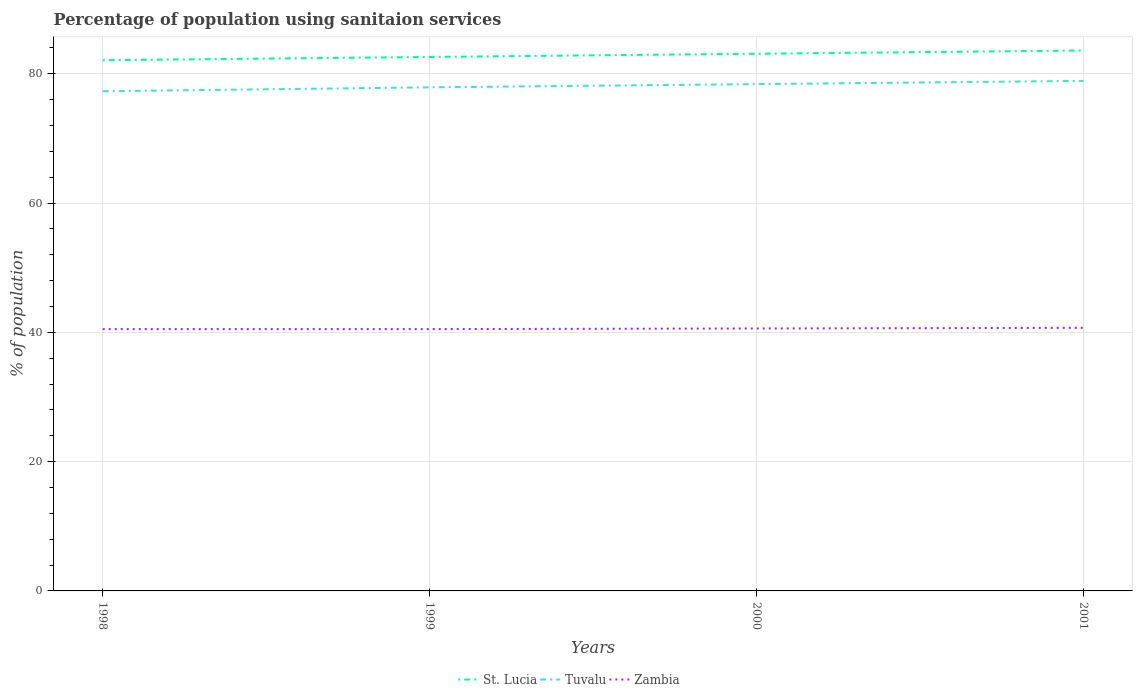How many different coloured lines are there?
Offer a very short reply. 3. Does the line corresponding to St. Lucia intersect with the line corresponding to Tuvalu?
Offer a very short reply. No. Is the number of lines equal to the number of legend labels?
Your answer should be very brief. Yes. Across all years, what is the maximum percentage of population using sanitaion services in Zambia?
Keep it short and to the point. 40.5. What is the total percentage of population using sanitaion services in Tuvalu in the graph?
Offer a very short reply. -1.6. What is the difference between the highest and the second highest percentage of population using sanitaion services in Tuvalu?
Make the answer very short. 1.6. What is the difference between the highest and the lowest percentage of population using sanitaion services in Tuvalu?
Keep it short and to the point. 2. Is the percentage of population using sanitaion services in St. Lucia strictly greater than the percentage of population using sanitaion services in Tuvalu over the years?
Provide a succinct answer. No. How many lines are there?
Offer a very short reply. 3. What is the difference between two consecutive major ticks on the Y-axis?
Your answer should be compact. 20. Does the graph contain any zero values?
Give a very brief answer. No. Where does the legend appear in the graph?
Give a very brief answer. Bottom center. How many legend labels are there?
Offer a terse response. 3. How are the legend labels stacked?
Offer a very short reply. Horizontal. What is the title of the graph?
Offer a terse response. Percentage of population using sanitaion services. Does "Bhutan" appear as one of the legend labels in the graph?
Your answer should be very brief. No. What is the label or title of the Y-axis?
Offer a very short reply. % of population. What is the % of population in St. Lucia in 1998?
Give a very brief answer. 82.1. What is the % of population in Tuvalu in 1998?
Make the answer very short. 77.3. What is the % of population of Zambia in 1998?
Give a very brief answer. 40.5. What is the % of population of St. Lucia in 1999?
Give a very brief answer. 82.6. What is the % of population of Tuvalu in 1999?
Offer a terse response. 77.9. What is the % of population in Zambia in 1999?
Give a very brief answer. 40.5. What is the % of population of St. Lucia in 2000?
Offer a very short reply. 83.1. What is the % of population in Tuvalu in 2000?
Give a very brief answer. 78.4. What is the % of population of Zambia in 2000?
Your answer should be very brief. 40.6. What is the % of population in St. Lucia in 2001?
Your response must be concise. 83.6. What is the % of population in Tuvalu in 2001?
Offer a very short reply. 78.9. What is the % of population of Zambia in 2001?
Offer a terse response. 40.7. Across all years, what is the maximum % of population in St. Lucia?
Make the answer very short. 83.6. Across all years, what is the maximum % of population in Tuvalu?
Ensure brevity in your answer.  78.9. Across all years, what is the maximum % of population in Zambia?
Offer a very short reply. 40.7. Across all years, what is the minimum % of population in St. Lucia?
Make the answer very short. 82.1. Across all years, what is the minimum % of population of Tuvalu?
Provide a short and direct response. 77.3. Across all years, what is the minimum % of population of Zambia?
Your response must be concise. 40.5. What is the total % of population of St. Lucia in the graph?
Offer a terse response. 331.4. What is the total % of population in Tuvalu in the graph?
Offer a terse response. 312.5. What is the total % of population in Zambia in the graph?
Offer a terse response. 162.3. What is the difference between the % of population in St. Lucia in 1998 and that in 1999?
Ensure brevity in your answer.  -0.5. What is the difference between the % of population in Tuvalu in 1998 and that in 1999?
Your response must be concise. -0.6. What is the difference between the % of population of Tuvalu in 1998 and that in 2000?
Offer a terse response. -1.1. What is the difference between the % of population of Zambia in 1998 and that in 2000?
Provide a short and direct response. -0.1. What is the difference between the % of population in St. Lucia in 1998 and that in 2001?
Provide a short and direct response. -1.5. What is the difference between the % of population in Tuvalu in 1998 and that in 2001?
Ensure brevity in your answer.  -1.6. What is the difference between the % of population of Zambia in 1998 and that in 2001?
Offer a terse response. -0.2. What is the difference between the % of population in Tuvalu in 1999 and that in 2000?
Give a very brief answer. -0.5. What is the difference between the % of population in Tuvalu in 1999 and that in 2001?
Offer a very short reply. -1. What is the difference between the % of population in Zambia in 1999 and that in 2001?
Provide a succinct answer. -0.2. What is the difference between the % of population of St. Lucia in 1998 and the % of population of Tuvalu in 1999?
Offer a terse response. 4.2. What is the difference between the % of population of St. Lucia in 1998 and the % of population of Zambia in 1999?
Give a very brief answer. 41.6. What is the difference between the % of population of Tuvalu in 1998 and the % of population of Zambia in 1999?
Your answer should be compact. 36.8. What is the difference between the % of population of St. Lucia in 1998 and the % of population of Zambia in 2000?
Offer a terse response. 41.5. What is the difference between the % of population of Tuvalu in 1998 and the % of population of Zambia in 2000?
Provide a succinct answer. 36.7. What is the difference between the % of population in St. Lucia in 1998 and the % of population in Tuvalu in 2001?
Ensure brevity in your answer.  3.2. What is the difference between the % of population in St. Lucia in 1998 and the % of population in Zambia in 2001?
Your answer should be very brief. 41.4. What is the difference between the % of population of Tuvalu in 1998 and the % of population of Zambia in 2001?
Make the answer very short. 36.6. What is the difference between the % of population in St. Lucia in 1999 and the % of population in Tuvalu in 2000?
Your answer should be very brief. 4.2. What is the difference between the % of population of Tuvalu in 1999 and the % of population of Zambia in 2000?
Ensure brevity in your answer.  37.3. What is the difference between the % of population of St. Lucia in 1999 and the % of population of Zambia in 2001?
Your answer should be very brief. 41.9. What is the difference between the % of population of Tuvalu in 1999 and the % of population of Zambia in 2001?
Your response must be concise. 37.2. What is the difference between the % of population in St. Lucia in 2000 and the % of population in Zambia in 2001?
Give a very brief answer. 42.4. What is the difference between the % of population in Tuvalu in 2000 and the % of population in Zambia in 2001?
Ensure brevity in your answer.  37.7. What is the average % of population of St. Lucia per year?
Ensure brevity in your answer.  82.85. What is the average % of population of Tuvalu per year?
Provide a succinct answer. 78.12. What is the average % of population in Zambia per year?
Your answer should be compact. 40.58. In the year 1998, what is the difference between the % of population in St. Lucia and % of population in Tuvalu?
Your response must be concise. 4.8. In the year 1998, what is the difference between the % of population in St. Lucia and % of population in Zambia?
Keep it short and to the point. 41.6. In the year 1998, what is the difference between the % of population in Tuvalu and % of population in Zambia?
Ensure brevity in your answer.  36.8. In the year 1999, what is the difference between the % of population of St. Lucia and % of population of Tuvalu?
Offer a terse response. 4.7. In the year 1999, what is the difference between the % of population of St. Lucia and % of population of Zambia?
Offer a very short reply. 42.1. In the year 1999, what is the difference between the % of population in Tuvalu and % of population in Zambia?
Your answer should be compact. 37.4. In the year 2000, what is the difference between the % of population of St. Lucia and % of population of Zambia?
Offer a terse response. 42.5. In the year 2000, what is the difference between the % of population of Tuvalu and % of population of Zambia?
Offer a very short reply. 37.8. In the year 2001, what is the difference between the % of population of St. Lucia and % of population of Zambia?
Your answer should be very brief. 42.9. In the year 2001, what is the difference between the % of population of Tuvalu and % of population of Zambia?
Provide a short and direct response. 38.2. What is the ratio of the % of population of St. Lucia in 1998 to that in 1999?
Offer a very short reply. 0.99. What is the ratio of the % of population of Tuvalu in 1998 to that in 1999?
Your answer should be compact. 0.99. What is the ratio of the % of population of Tuvalu in 1998 to that in 2000?
Keep it short and to the point. 0.99. What is the ratio of the % of population in St. Lucia in 1998 to that in 2001?
Offer a very short reply. 0.98. What is the ratio of the % of population of Tuvalu in 1998 to that in 2001?
Give a very brief answer. 0.98. What is the ratio of the % of population in Zambia in 1998 to that in 2001?
Provide a short and direct response. 1. What is the ratio of the % of population of Tuvalu in 1999 to that in 2001?
Your answer should be very brief. 0.99. What is the ratio of the % of population of Tuvalu in 2000 to that in 2001?
Make the answer very short. 0.99. What is the ratio of the % of population of Zambia in 2000 to that in 2001?
Provide a short and direct response. 1. What is the difference between the highest and the second highest % of population of St. Lucia?
Give a very brief answer. 0.5. What is the difference between the highest and the second highest % of population of Tuvalu?
Make the answer very short. 0.5. What is the difference between the highest and the second highest % of population of Zambia?
Offer a terse response. 0.1. What is the difference between the highest and the lowest % of population of Tuvalu?
Provide a succinct answer. 1.6. What is the difference between the highest and the lowest % of population of Zambia?
Offer a terse response. 0.2. 